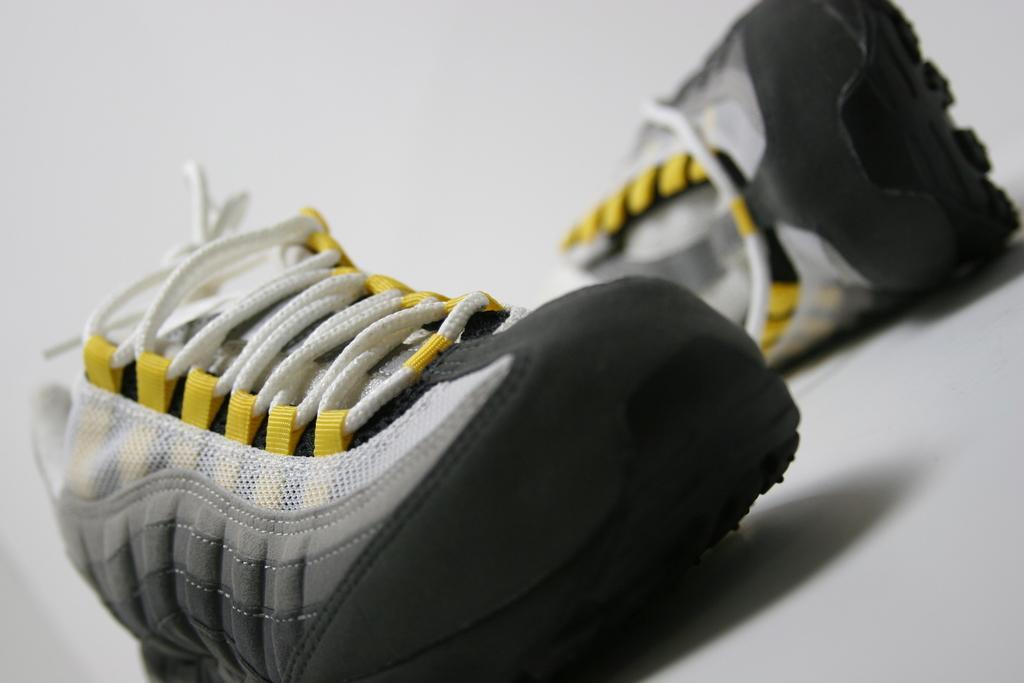In one or two sentences, can you explain what this image depicts? In this picture I can see pair of shoes on an object. 